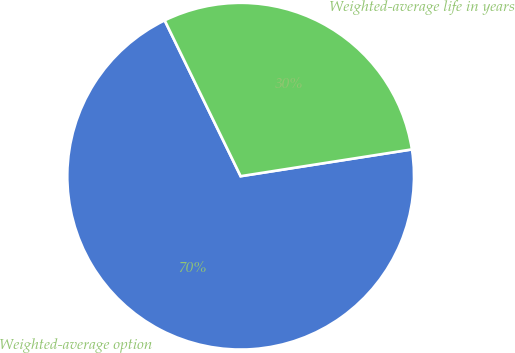<chart> <loc_0><loc_0><loc_500><loc_500><pie_chart><fcel>Weighted-average option<fcel>Weighted-average life in years<nl><fcel>70.25%<fcel>29.75%<nl></chart> 